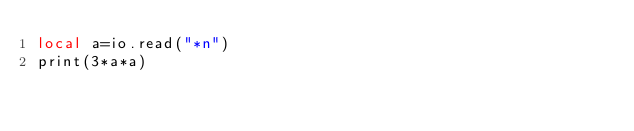Convert code to text. <code><loc_0><loc_0><loc_500><loc_500><_MoonScript_>local a=io.read("*n")
print(3*a*a)</code> 